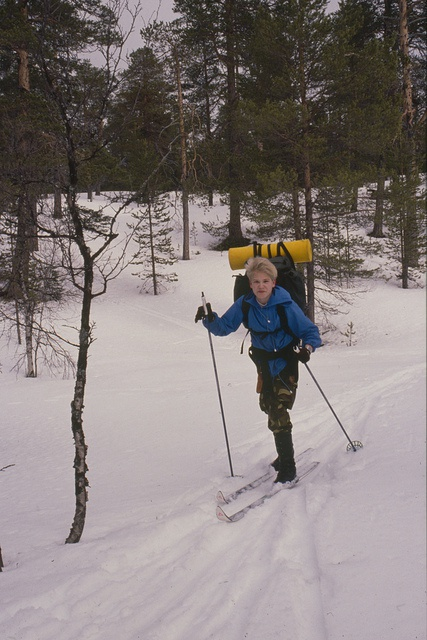Describe the objects in this image and their specific colors. I can see people in black, navy, darkblue, and gray tones, backpack in black, olive, and orange tones, and skis in black, darkgray, and gray tones in this image. 